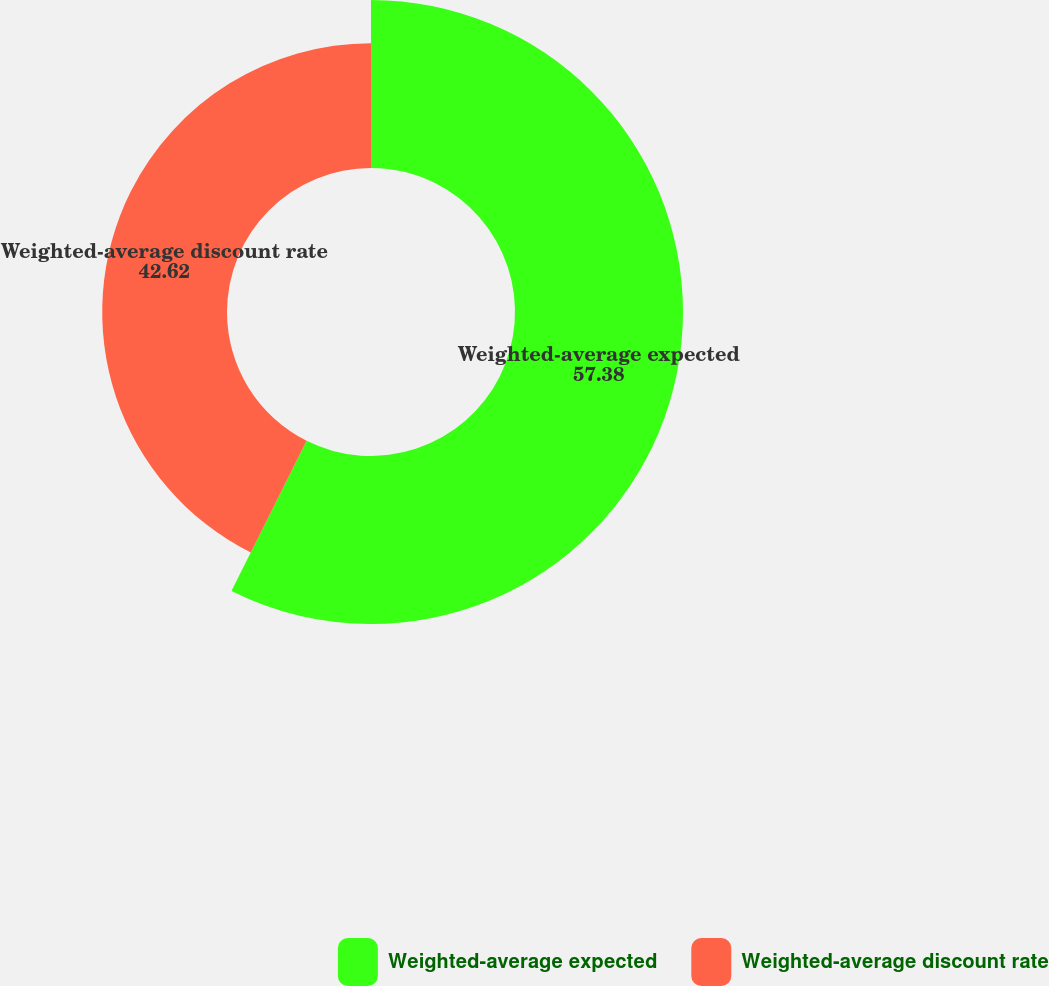Convert chart. <chart><loc_0><loc_0><loc_500><loc_500><pie_chart><fcel>Weighted-average expected<fcel>Weighted-average discount rate<nl><fcel>57.38%<fcel>42.62%<nl></chart> 